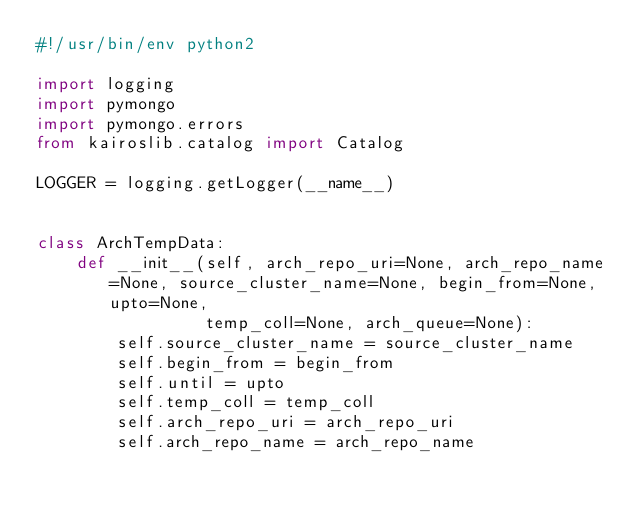<code> <loc_0><loc_0><loc_500><loc_500><_Python_>#!/usr/bin/env python2

import logging
import pymongo
import pymongo.errors
from kairoslib.catalog import Catalog

LOGGER = logging.getLogger(__name__)


class ArchTempData:
    def __init__(self, arch_repo_uri=None, arch_repo_name=None, source_cluster_name=None, begin_from=None, upto=None,
                 temp_coll=None, arch_queue=None):
        self.source_cluster_name = source_cluster_name
        self.begin_from = begin_from
        self.until = upto
        self.temp_coll = temp_coll
        self.arch_repo_uri = arch_repo_uri
        self.arch_repo_name = arch_repo_name</code> 